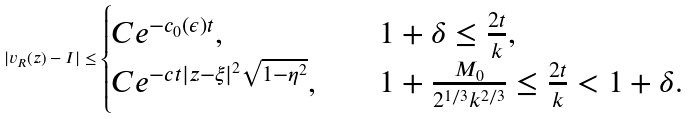Convert formula to latex. <formula><loc_0><loc_0><loc_500><loc_500>| v _ { R } ( z ) - I | \leq \begin{cases} C e ^ { - c _ { 0 } ( \epsilon ) t } , \quad & 1 + \delta \leq \frac { 2 t } { k } , \\ C e ^ { - c t | z - \xi | ^ { 2 } \sqrt { 1 - \eta ^ { 2 } } } , \quad & 1 + \frac { M _ { 0 } } { 2 ^ { 1 / 3 } k ^ { 2 / 3 } } \leq \frac { 2 t } { k } < 1 + \delta . \end{cases}</formula> 